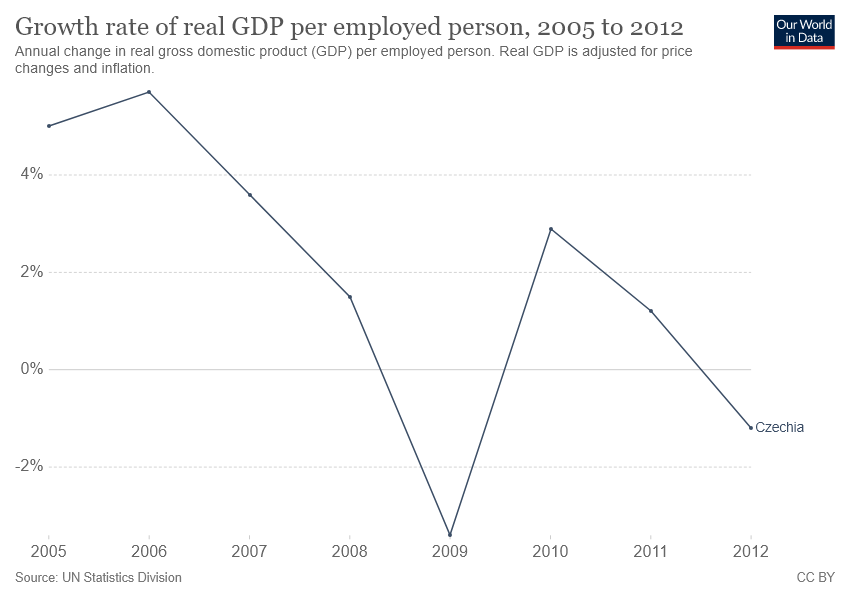Specify some key components in this picture. The approximate difference between the highest and lowest point is approximately 9. The growth of GDP reached its peak in 2006. 